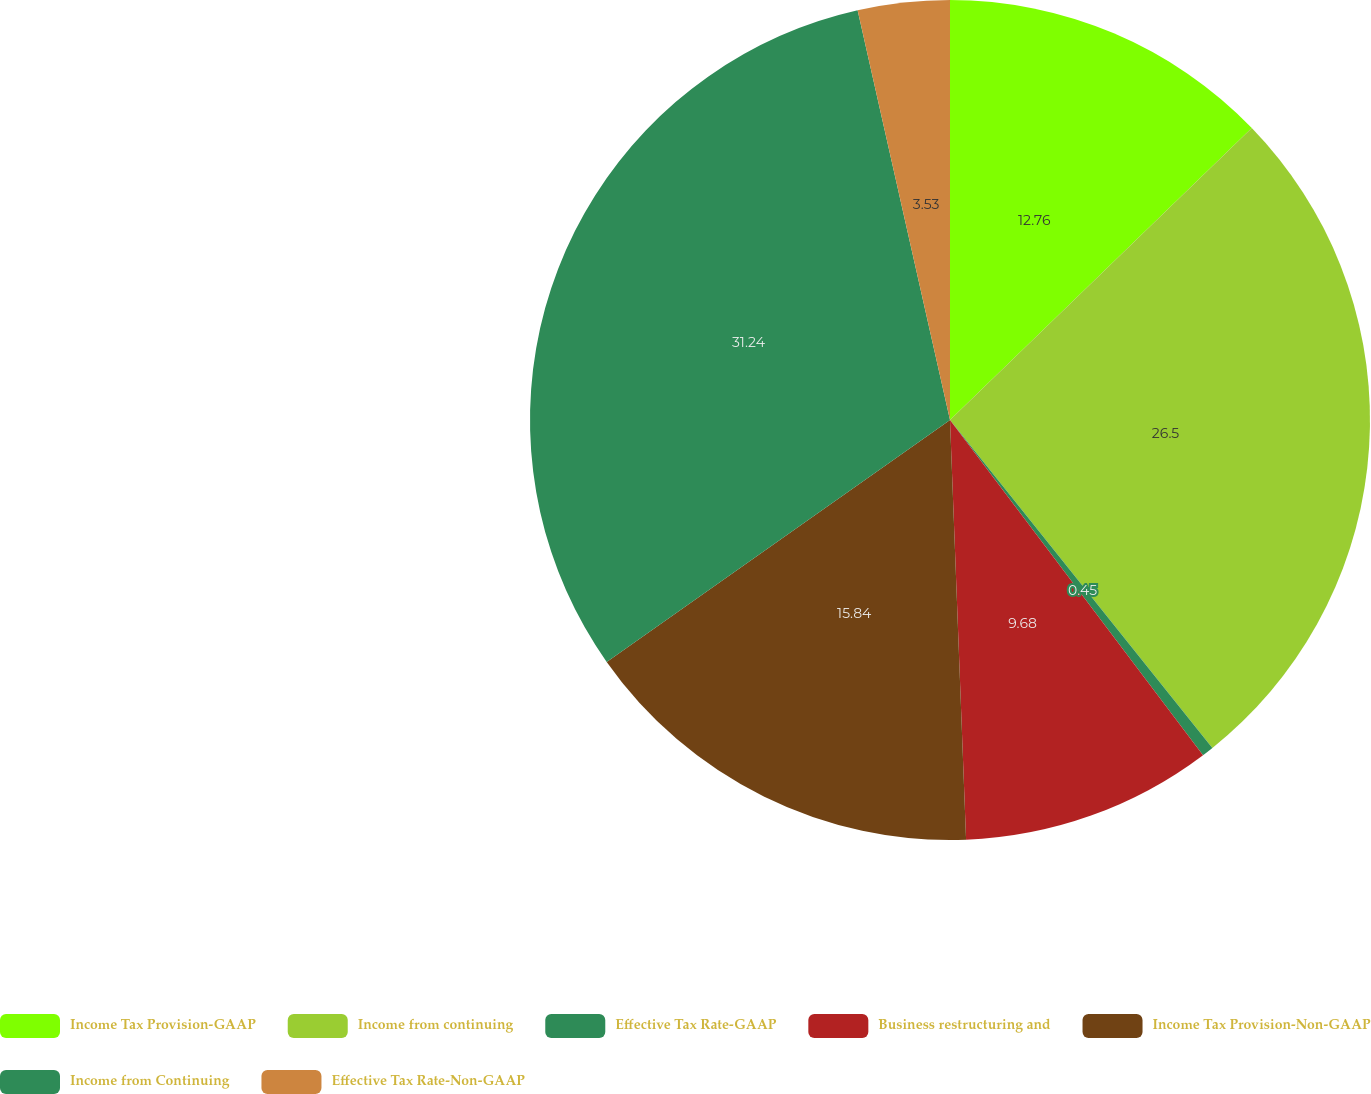<chart> <loc_0><loc_0><loc_500><loc_500><pie_chart><fcel>Income Tax Provision-GAAP<fcel>Income from continuing<fcel>Effective Tax Rate-GAAP<fcel>Business restructuring and<fcel>Income Tax Provision-Non-GAAP<fcel>Income from Continuing<fcel>Effective Tax Rate-Non-GAAP<nl><fcel>12.76%<fcel>26.5%<fcel>0.45%<fcel>9.68%<fcel>15.84%<fcel>31.24%<fcel>3.53%<nl></chart> 